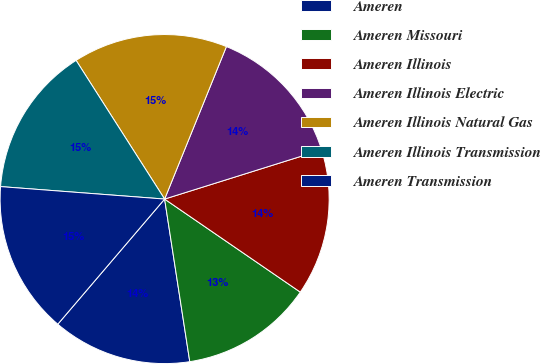Convert chart. <chart><loc_0><loc_0><loc_500><loc_500><pie_chart><fcel>Ameren<fcel>Ameren Missouri<fcel>Ameren Illinois<fcel>Ameren Illinois Electric<fcel>Ameren Illinois Natural Gas<fcel>Ameren Illinois Transmission<fcel>Ameren Transmission<nl><fcel>13.69%<fcel>12.99%<fcel>14.4%<fcel>14.04%<fcel>15.17%<fcel>14.75%<fcel>14.96%<nl></chart> 